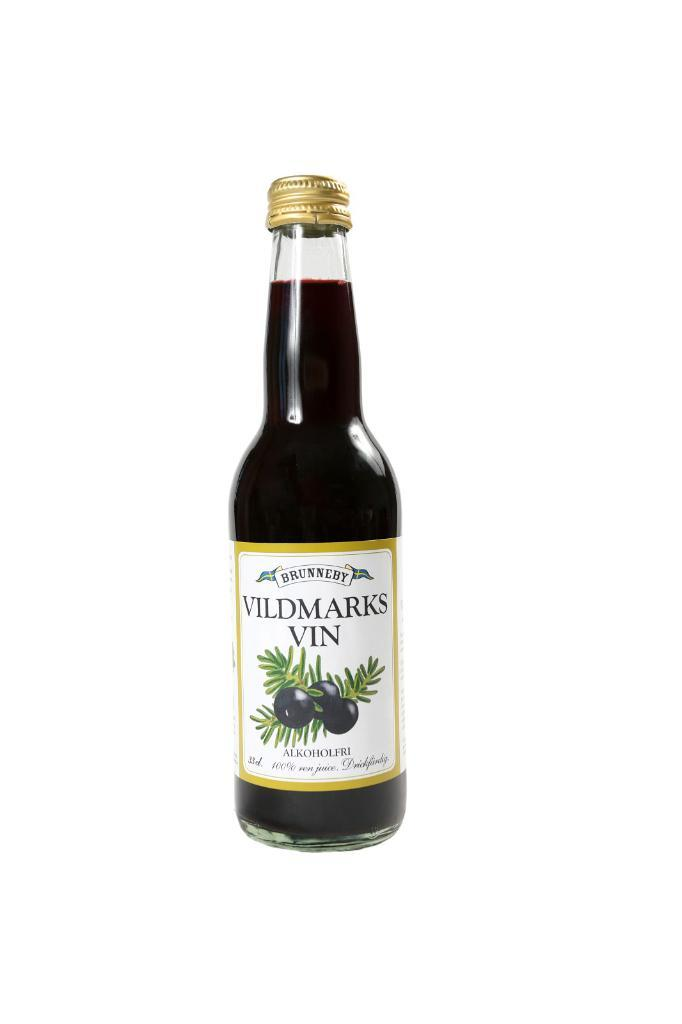What object is present in the picture? There is a bottle in the picture. What is inside the bottle? The bottle contains some liquid. What color is the background of the image? The background of the image is white. What type of bean is visible in the picture? There is no bean present in the picture; it only contains a bottle with liquid. Is there a shoe visible in the picture? No, there is no shoe present in the picture. 